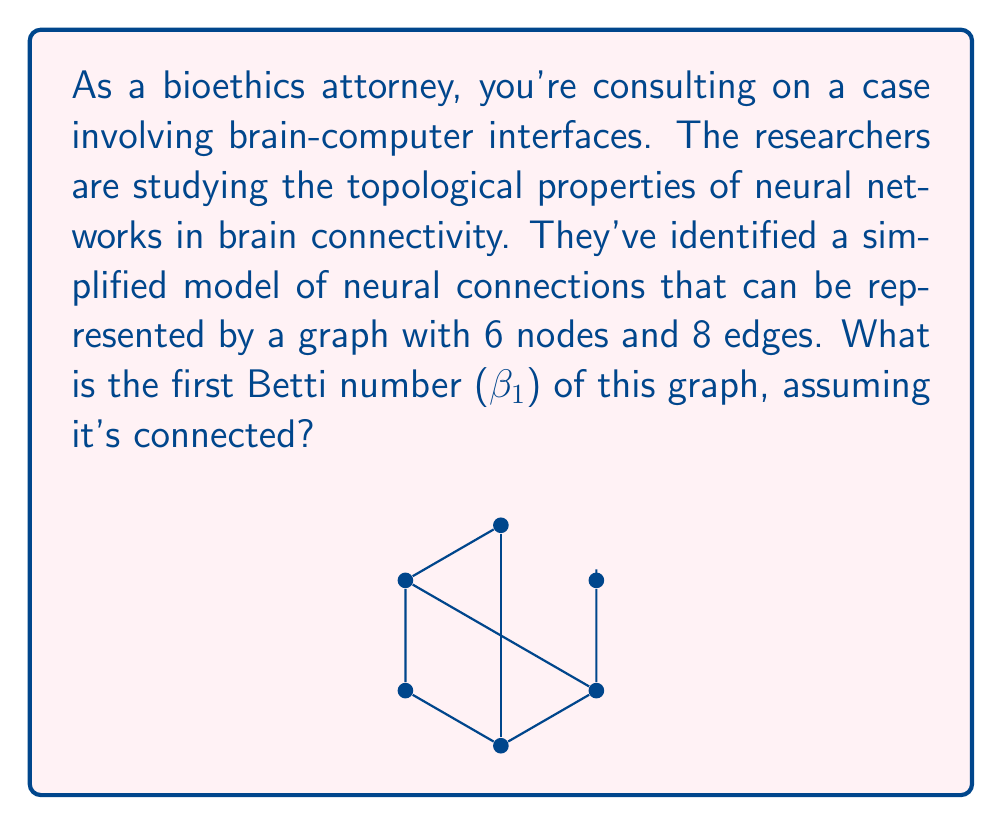Can you solve this math problem? To solve this problem, we need to understand the concept of the first Betti number and how it relates to graphs:

1) The first Betti number (β₁) is a topological invariant that, for graphs, represents the number of independent cycles or "holes" in the graph.

2) For a connected graph, β₁ can be calculated using the formula:

   $$\beta_1 = |E| - |V| + 1$$

   Where |E| is the number of edges and |V| is the number of vertices.

3) In this case, we have:
   - |V| = 6 (number of nodes)
   - |E| = 8 (number of edges)

4) Plugging these values into the formula:

   $$\beta_1 = 8 - 6 + 1 = 3$$

5) This result tells us that there are 3 independent cycles in the graph.

6) We can verify this visually:
   - The outer pentagon forms one cycle
   - The triangle formed by nodes 0, 1, and 5 forms another cycle
   - The quadrilateral formed by nodes 0, 3, 5, and 1 forms the third cycle

These three cycles cannot be reduced to combinations of each other, confirming that β₁ = 3.
Answer: 3 